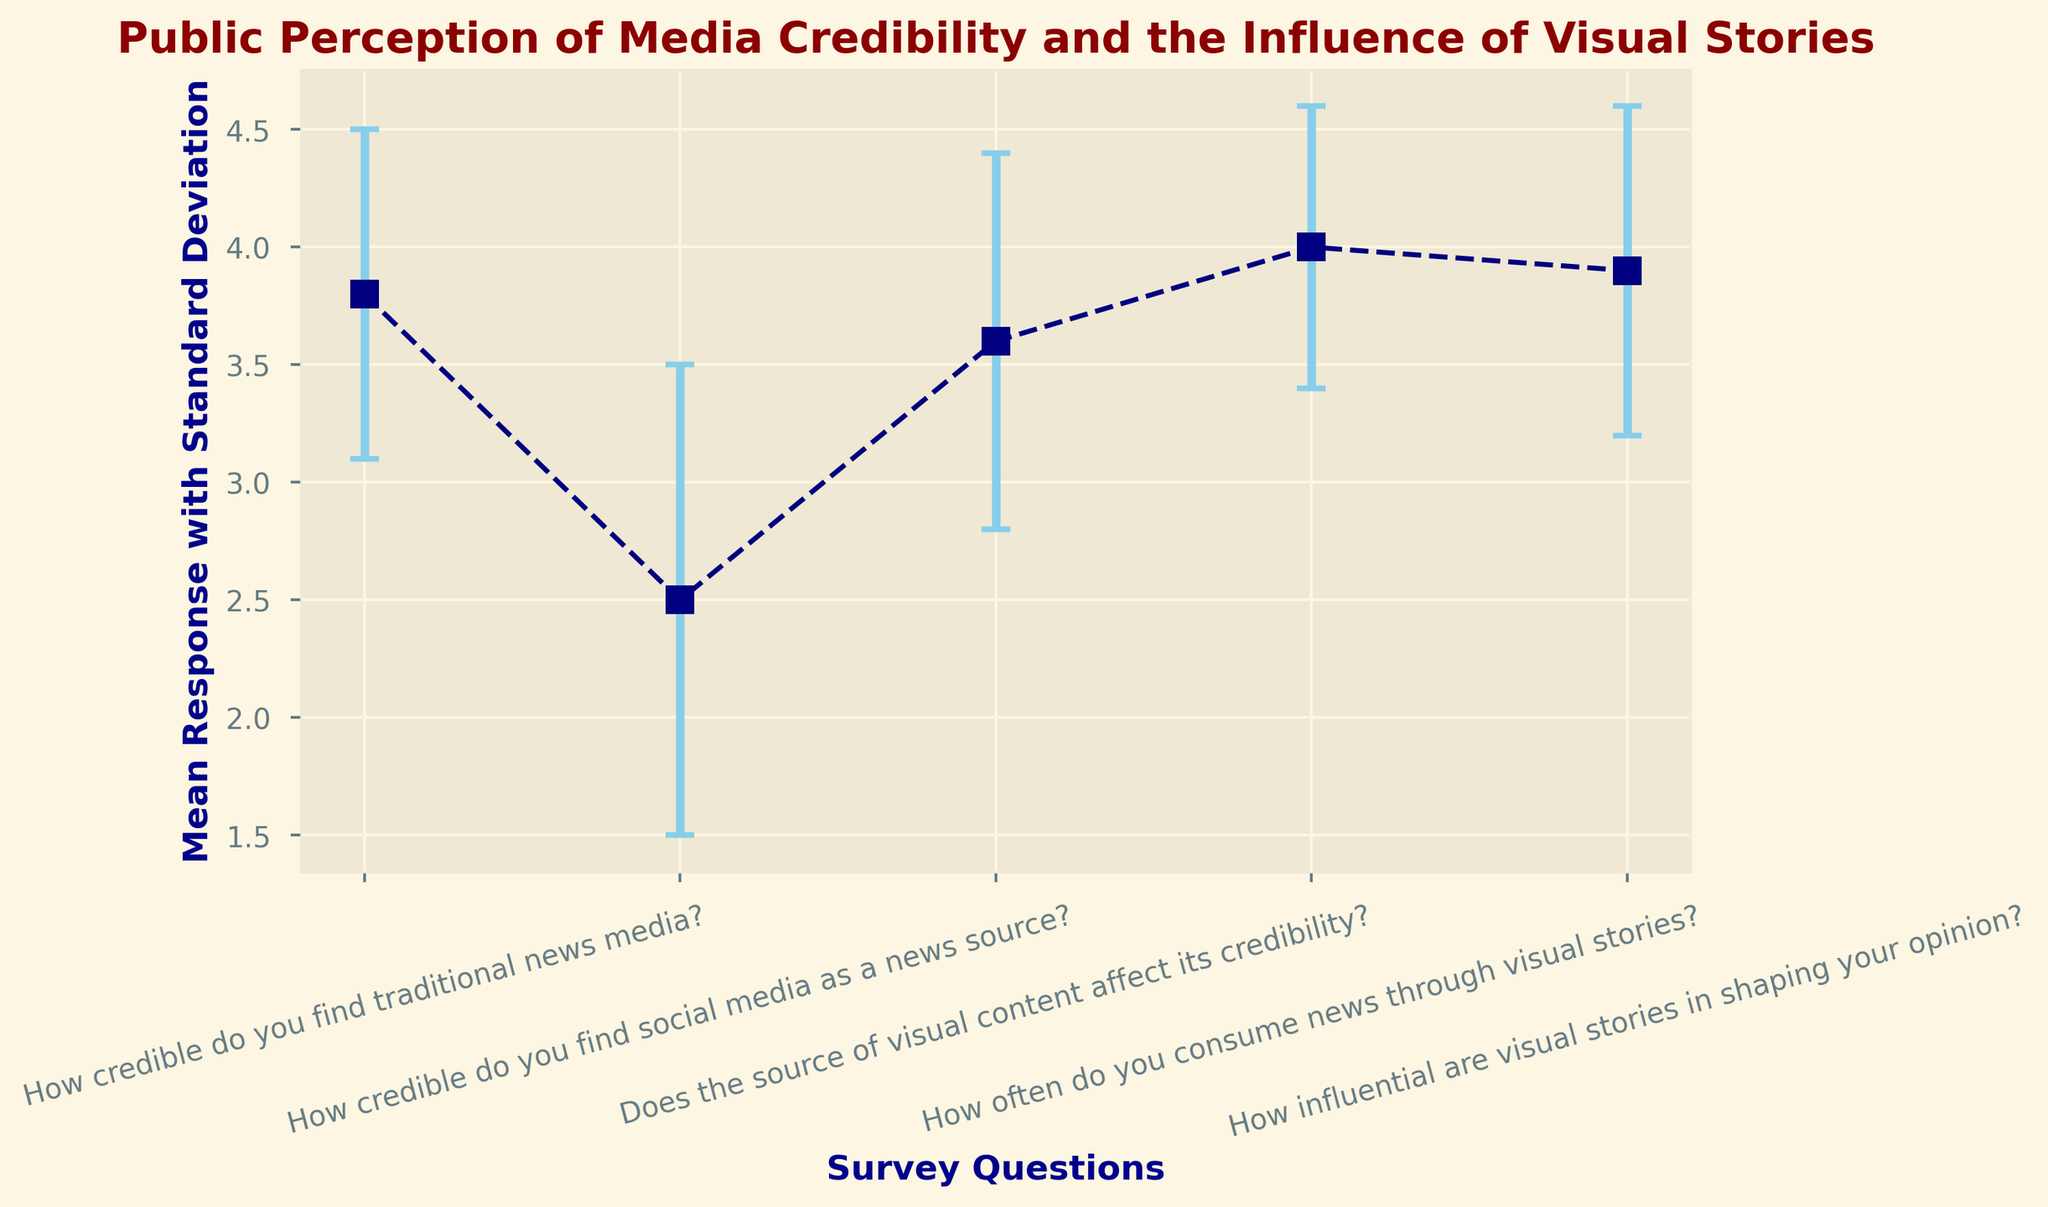How many survey questions have a mean response of 3.8 or higher? We look at the mean responses in the figure and count how many are 3.8 or higher. The questions "How credible do you find traditional news media?" (3.8), "How often do you consume news through visual stories?" (4.0), and "How influential are visual stories in shaping your opinion?" (3.9) all meet this criteria. That's three questions.
Answer: 3 What is the difference in mean response between the most and least credible news sources? Identify the maximum and minimum mean responses regarding credibility. Traditional news media has a mean of 3.8, and social media has a mean of 2.5. The difference is 3.8 - 2.5 = 1.3.
Answer: 1.3 Which question has the smallest associated uncertainty (standard deviation)? By looking at the error bars, we can identify that the smallest standard deviation is associated with "How often do you consume news through visual stories?" which has a standard deviation of 0.6.
Answer: How often do you consume news through visual stories? How does the perceived influence of visual stories compare to their consumption frequency? Compare the mean responses of "How influential are visual stories in shaping your opinion?" (3.9) and "How often do you consume news through visual stories?" (4.0). The influence (3.9) is slightly less than the consumption frequency (4.0).
Answer: Consumption frequency is higher What is the total mean response for all the questions? Sum up the mean responses for all survey questions: 3.8 + 2.5 + 3.6 + 4.0 + 3.9 = 17.8.
Answer: 17.8 Which survey question has the largest error bar? Locate the survey question with the largest error bar visually. "How credible do you find social media as a news source?" has the largest standard deviation of 1.0, indicating the largest error bar.
Answer: How credible do you find social media as a news source? What is the average standard deviation for all survey questions? Add up all the standard deviations and divide by the number of questions: (0.7 + 1.0 + 0.8 + 0.6 + 0.7) / 5 = 3.8 / 5 = 0.76.
Answer: 0.76 Is the consumption of visual stories or their influence more varied (higher standard deviation)? Compare the standard deviations of "How often do you consume news through visual stories?" (0.6) and "How influential are visual stories in shaping your opinion?" (0.7). The influence (0.7) is more varied than the consumption (0.6).
Answer: Influence is more varied What is the second highest mean response and to which question does it correspond? Find the second highest mean response after identifying the highest (4.0). The second highest is 3.9, which corresponds to "How influential are visual stories in shaping your opinion?".
Answer: How influential are visual stories in shaping your opinion? 